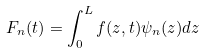Convert formula to latex. <formula><loc_0><loc_0><loc_500><loc_500>F _ { n } ( t ) = \int _ { 0 } ^ { L } f ( z , t ) \psi _ { n } ( z ) d z</formula> 